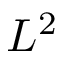Convert formula to latex. <formula><loc_0><loc_0><loc_500><loc_500>L ^ { 2 }</formula> 